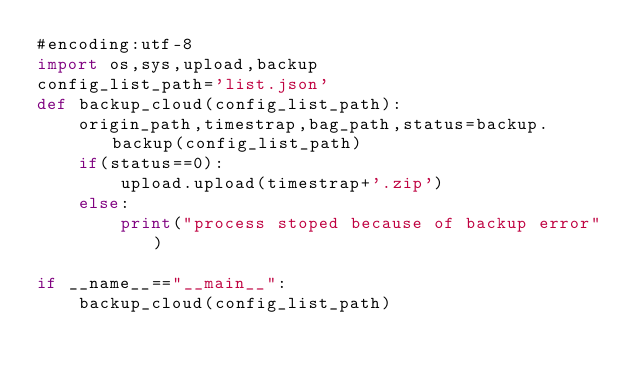<code> <loc_0><loc_0><loc_500><loc_500><_Python_>#encoding:utf-8
import os,sys,upload,backup
config_list_path='list.json'
def backup_cloud(config_list_path):
    origin_path,timestrap,bag_path,status=backup.backup(config_list_path)
    if(status==0):
        upload.upload(timestrap+'.zip')
    else:
        print("process stoped because of backup error")

if __name__=="__main__":
    backup_cloud(config_list_path)
</code> 